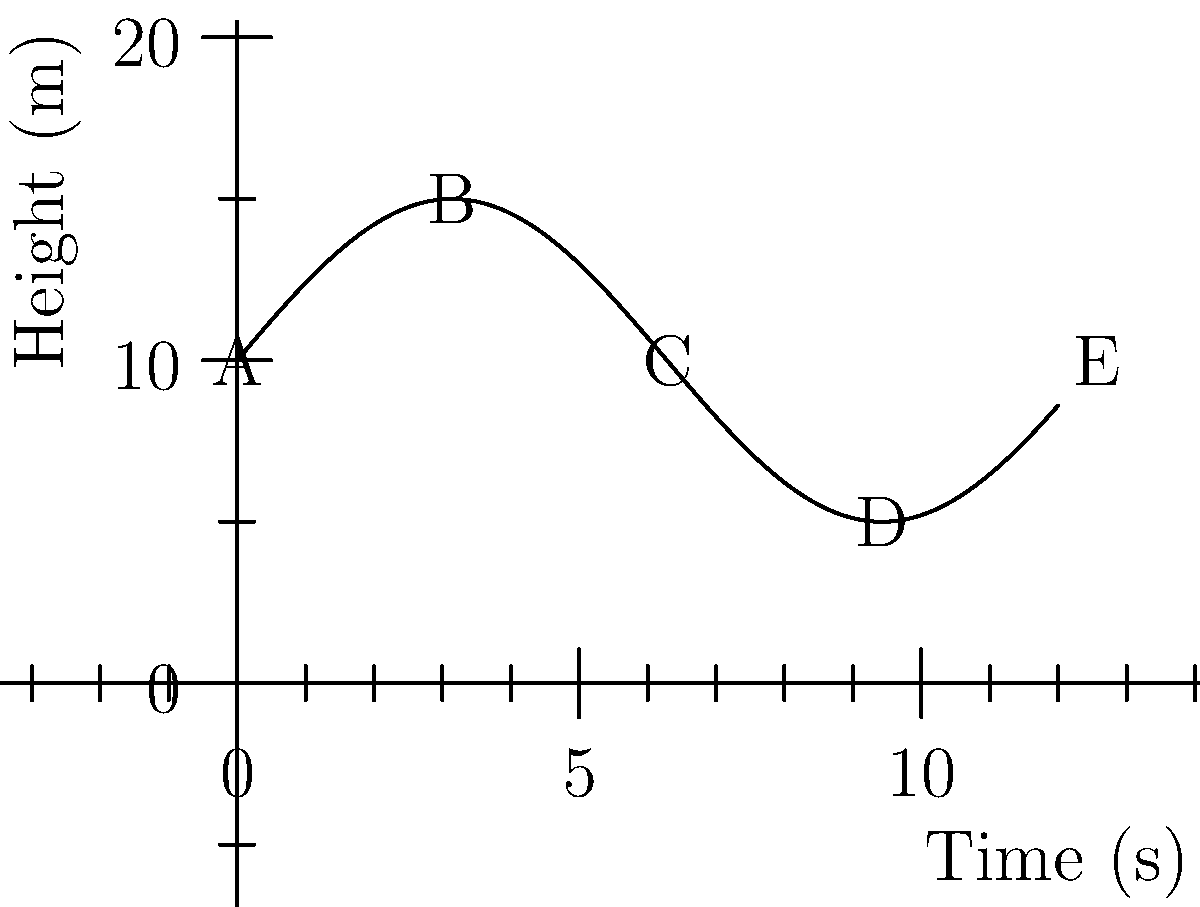As a rollercoaster operator, you're analyzing the height profile of a new ride. The graph shows the height of the rollercoaster over time. At which point is the rate of change of the rollercoaster's height the greatest in magnitude? To find the point with the greatest rate of change in magnitude, we need to analyze the slope of the curve at different points:

1. The rate of change is represented by the slope of the curve at any given point.
2. The steeper the curve, the greater the magnitude of the rate of change.
3. We need to compare the steepness at points A, B, C, D, and E.

4. At point A: The curve is rising steeply, indicating a high positive rate of change.
5. At point B: The curve is leveling off, indicating a low rate of change.
6. At point C: The curve is falling steeply, indicating a high negative rate of change.
7. At point D: The curve is rising steeply again, indicating a high positive rate of change.
8. At point E: Similar to point B, the curve is leveling off.

9. The steepest parts of the curve appear to be between A and B (rising) and between C and D (falling).
10. The falling section between C and D looks slightly steeper than the rising section between A and B.

Therefore, the point with the greatest rate of change in magnitude is point C, where the rollercoaster begins its steepest descent.
Answer: C 